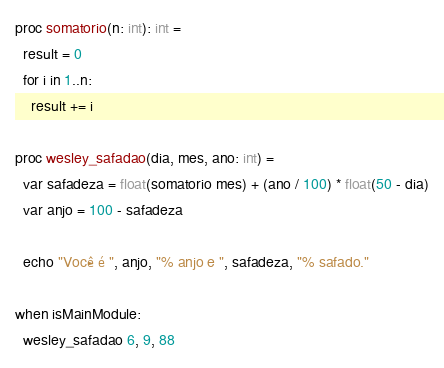Convert code to text. <code><loc_0><loc_0><loc_500><loc_500><_Nim_>proc somatorio(n: int): int =
  result = 0
  for i in 1..n:
    result += i

proc wesley_safadao(dia, mes, ano: int) =
  var safadeza = float(somatorio mes) + (ano / 100) * float(50 - dia)
  var anjo = 100 - safadeza

  echo "Você é ", anjo, "% anjo e ", safadeza, "% safado."

when isMainModule:
  wesley_safadao 6, 9, 88
</code> 